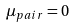<formula> <loc_0><loc_0><loc_500><loc_500>\mu _ { p a i r } = 0</formula> 